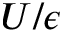Convert formula to latex. <formula><loc_0><loc_0><loc_500><loc_500>U / \epsilon</formula> 